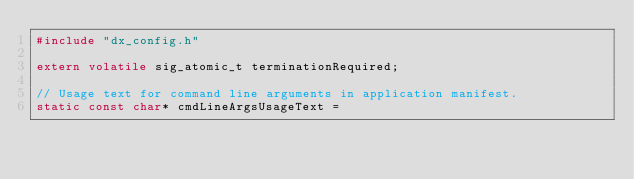Convert code to text. <code><loc_0><loc_0><loc_500><loc_500><_C_>#include "dx_config.h"

extern volatile sig_atomic_t terminationRequired;

// Usage text for command line arguments in application manifest.
static const char* cmdLineArgsUsageText =</code> 